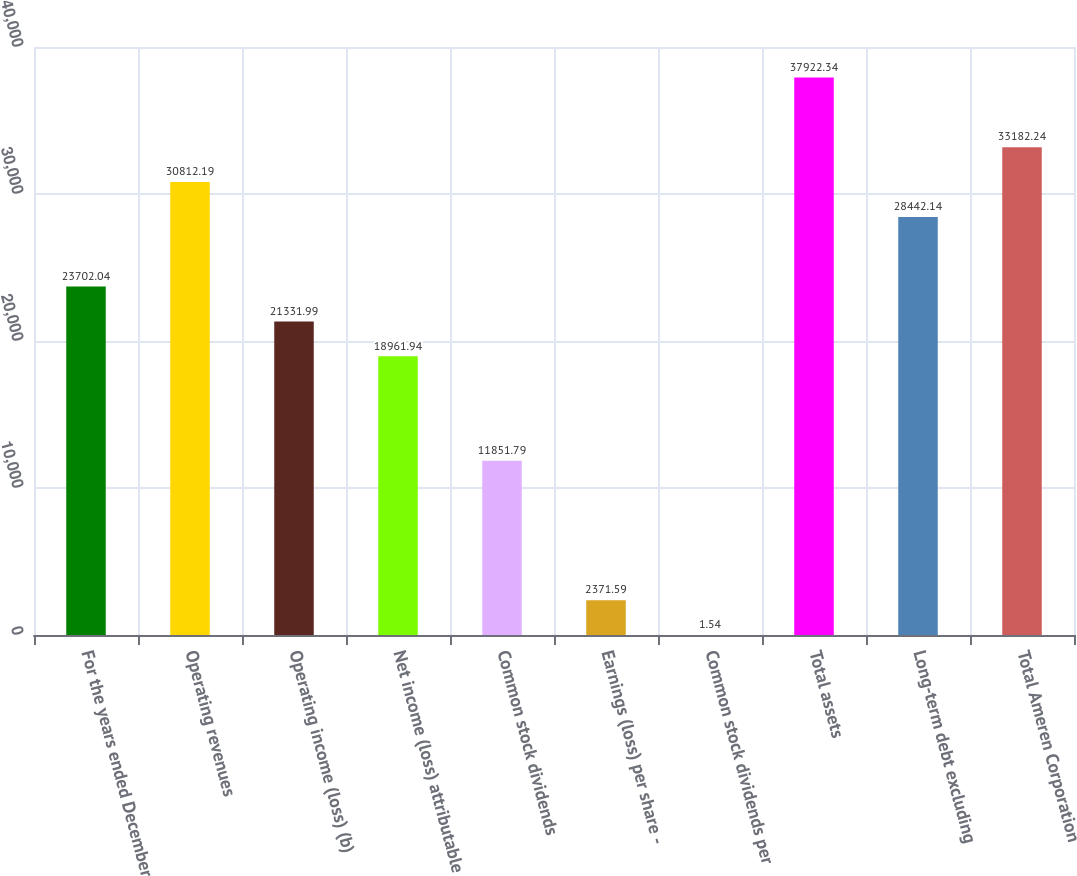Convert chart to OTSL. <chart><loc_0><loc_0><loc_500><loc_500><bar_chart><fcel>For the years ended December<fcel>Operating revenues<fcel>Operating income (loss) (b)<fcel>Net income (loss) attributable<fcel>Common stock dividends<fcel>Earnings (loss) per share -<fcel>Common stock dividends per<fcel>Total assets<fcel>Long-term debt excluding<fcel>Total Ameren Corporation<nl><fcel>23702<fcel>30812.2<fcel>21332<fcel>18961.9<fcel>11851.8<fcel>2371.59<fcel>1.54<fcel>37922.3<fcel>28442.1<fcel>33182.2<nl></chart> 